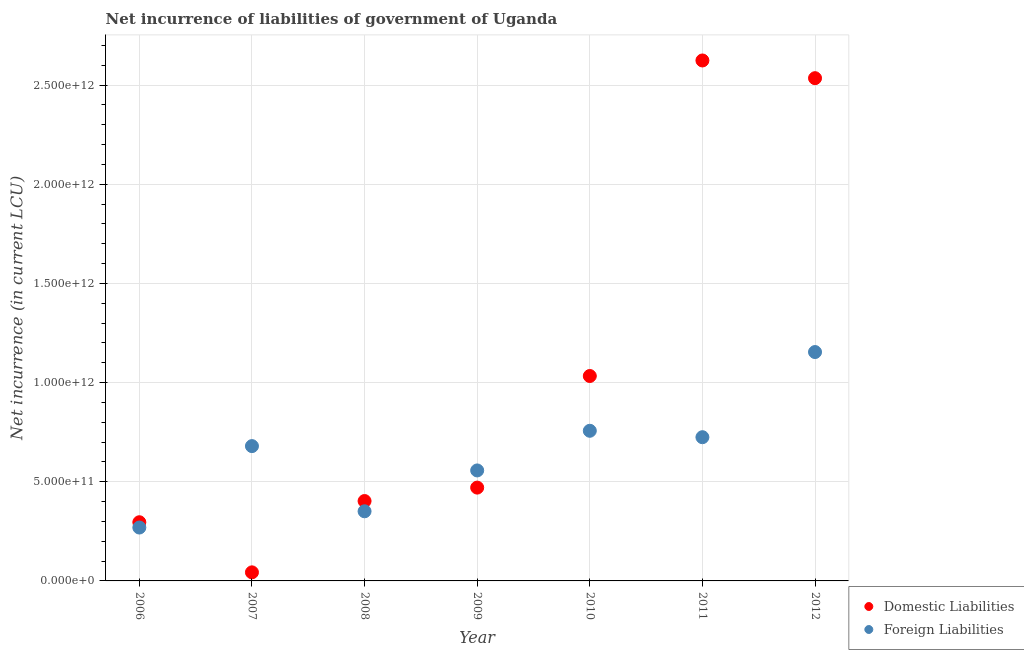How many different coloured dotlines are there?
Provide a succinct answer. 2. Is the number of dotlines equal to the number of legend labels?
Provide a succinct answer. Yes. What is the net incurrence of foreign liabilities in 2012?
Provide a succinct answer. 1.15e+12. Across all years, what is the maximum net incurrence of domestic liabilities?
Your answer should be compact. 2.62e+12. Across all years, what is the minimum net incurrence of domestic liabilities?
Provide a short and direct response. 4.32e+1. What is the total net incurrence of domestic liabilities in the graph?
Keep it short and to the point. 7.40e+12. What is the difference between the net incurrence of domestic liabilities in 2009 and that in 2010?
Your answer should be very brief. -5.63e+11. What is the difference between the net incurrence of foreign liabilities in 2010 and the net incurrence of domestic liabilities in 2009?
Give a very brief answer. 2.86e+11. What is the average net incurrence of foreign liabilities per year?
Your answer should be compact. 6.42e+11. In the year 2008, what is the difference between the net incurrence of domestic liabilities and net incurrence of foreign liabilities?
Give a very brief answer. 5.17e+1. What is the ratio of the net incurrence of foreign liabilities in 2007 to that in 2010?
Offer a terse response. 0.9. Is the net incurrence of domestic liabilities in 2008 less than that in 2012?
Provide a succinct answer. Yes. Is the difference between the net incurrence of domestic liabilities in 2010 and 2011 greater than the difference between the net incurrence of foreign liabilities in 2010 and 2011?
Your response must be concise. No. What is the difference between the highest and the second highest net incurrence of foreign liabilities?
Ensure brevity in your answer.  3.97e+11. What is the difference between the highest and the lowest net incurrence of foreign liabilities?
Your response must be concise. 8.85e+11. In how many years, is the net incurrence of domestic liabilities greater than the average net incurrence of domestic liabilities taken over all years?
Your answer should be very brief. 2. Is the sum of the net incurrence of foreign liabilities in 2009 and 2010 greater than the maximum net incurrence of domestic liabilities across all years?
Keep it short and to the point. No. How many dotlines are there?
Offer a terse response. 2. What is the difference between two consecutive major ticks on the Y-axis?
Your response must be concise. 5.00e+11. How many legend labels are there?
Provide a short and direct response. 2. How are the legend labels stacked?
Your answer should be very brief. Vertical. What is the title of the graph?
Provide a succinct answer. Net incurrence of liabilities of government of Uganda. Does "Female labourers" appear as one of the legend labels in the graph?
Your answer should be compact. No. What is the label or title of the Y-axis?
Provide a succinct answer. Net incurrence (in current LCU). What is the Net incurrence (in current LCU) of Domestic Liabilities in 2006?
Provide a short and direct response. 2.96e+11. What is the Net incurrence (in current LCU) of Foreign Liabilities in 2006?
Keep it short and to the point. 2.69e+11. What is the Net incurrence (in current LCU) of Domestic Liabilities in 2007?
Your answer should be very brief. 4.32e+1. What is the Net incurrence (in current LCU) of Foreign Liabilities in 2007?
Offer a very short reply. 6.80e+11. What is the Net incurrence (in current LCU) in Domestic Liabilities in 2008?
Provide a short and direct response. 4.03e+11. What is the Net incurrence (in current LCU) of Foreign Liabilities in 2008?
Ensure brevity in your answer.  3.51e+11. What is the Net incurrence (in current LCU) in Domestic Liabilities in 2009?
Make the answer very short. 4.70e+11. What is the Net incurrence (in current LCU) in Foreign Liabilities in 2009?
Your answer should be very brief. 5.57e+11. What is the Net incurrence (in current LCU) in Domestic Liabilities in 2010?
Your answer should be compact. 1.03e+12. What is the Net incurrence (in current LCU) in Foreign Liabilities in 2010?
Keep it short and to the point. 7.57e+11. What is the Net incurrence (in current LCU) in Domestic Liabilities in 2011?
Make the answer very short. 2.62e+12. What is the Net incurrence (in current LCU) of Foreign Liabilities in 2011?
Provide a short and direct response. 7.25e+11. What is the Net incurrence (in current LCU) of Domestic Liabilities in 2012?
Your answer should be very brief. 2.53e+12. What is the Net incurrence (in current LCU) in Foreign Liabilities in 2012?
Your answer should be very brief. 1.15e+12. Across all years, what is the maximum Net incurrence (in current LCU) in Domestic Liabilities?
Offer a terse response. 2.62e+12. Across all years, what is the maximum Net incurrence (in current LCU) of Foreign Liabilities?
Keep it short and to the point. 1.15e+12. Across all years, what is the minimum Net incurrence (in current LCU) in Domestic Liabilities?
Your answer should be compact. 4.32e+1. Across all years, what is the minimum Net incurrence (in current LCU) of Foreign Liabilities?
Provide a short and direct response. 2.69e+11. What is the total Net incurrence (in current LCU) of Domestic Liabilities in the graph?
Ensure brevity in your answer.  7.40e+12. What is the total Net incurrence (in current LCU) of Foreign Liabilities in the graph?
Offer a very short reply. 4.49e+12. What is the difference between the Net incurrence (in current LCU) in Domestic Liabilities in 2006 and that in 2007?
Your answer should be very brief. 2.53e+11. What is the difference between the Net incurrence (in current LCU) in Foreign Liabilities in 2006 and that in 2007?
Provide a short and direct response. -4.11e+11. What is the difference between the Net incurrence (in current LCU) in Domestic Liabilities in 2006 and that in 2008?
Offer a terse response. -1.07e+11. What is the difference between the Net incurrence (in current LCU) of Foreign Liabilities in 2006 and that in 2008?
Your response must be concise. -8.19e+1. What is the difference between the Net incurrence (in current LCU) in Domestic Liabilities in 2006 and that in 2009?
Give a very brief answer. -1.75e+11. What is the difference between the Net incurrence (in current LCU) of Foreign Liabilities in 2006 and that in 2009?
Make the answer very short. -2.88e+11. What is the difference between the Net incurrence (in current LCU) of Domestic Liabilities in 2006 and that in 2010?
Give a very brief answer. -7.37e+11. What is the difference between the Net incurrence (in current LCU) of Foreign Liabilities in 2006 and that in 2010?
Keep it short and to the point. -4.88e+11. What is the difference between the Net incurrence (in current LCU) of Domestic Liabilities in 2006 and that in 2011?
Your answer should be very brief. -2.33e+12. What is the difference between the Net incurrence (in current LCU) in Foreign Liabilities in 2006 and that in 2011?
Offer a terse response. -4.55e+11. What is the difference between the Net incurrence (in current LCU) in Domestic Liabilities in 2006 and that in 2012?
Provide a succinct answer. -2.24e+12. What is the difference between the Net incurrence (in current LCU) in Foreign Liabilities in 2006 and that in 2012?
Provide a succinct answer. -8.85e+11. What is the difference between the Net incurrence (in current LCU) in Domestic Liabilities in 2007 and that in 2008?
Ensure brevity in your answer.  -3.60e+11. What is the difference between the Net incurrence (in current LCU) in Foreign Liabilities in 2007 and that in 2008?
Your answer should be compact. 3.29e+11. What is the difference between the Net incurrence (in current LCU) of Domestic Liabilities in 2007 and that in 2009?
Your answer should be very brief. -4.27e+11. What is the difference between the Net incurrence (in current LCU) in Foreign Liabilities in 2007 and that in 2009?
Offer a very short reply. 1.23e+11. What is the difference between the Net incurrence (in current LCU) in Domestic Liabilities in 2007 and that in 2010?
Keep it short and to the point. -9.90e+11. What is the difference between the Net incurrence (in current LCU) in Foreign Liabilities in 2007 and that in 2010?
Your answer should be very brief. -7.73e+1. What is the difference between the Net incurrence (in current LCU) of Domestic Liabilities in 2007 and that in 2011?
Offer a terse response. -2.58e+12. What is the difference between the Net incurrence (in current LCU) of Foreign Liabilities in 2007 and that in 2011?
Provide a succinct answer. -4.49e+1. What is the difference between the Net incurrence (in current LCU) of Domestic Liabilities in 2007 and that in 2012?
Keep it short and to the point. -2.49e+12. What is the difference between the Net incurrence (in current LCU) in Foreign Liabilities in 2007 and that in 2012?
Your answer should be very brief. -4.74e+11. What is the difference between the Net incurrence (in current LCU) of Domestic Liabilities in 2008 and that in 2009?
Give a very brief answer. -6.77e+1. What is the difference between the Net incurrence (in current LCU) of Foreign Liabilities in 2008 and that in 2009?
Your answer should be compact. -2.06e+11. What is the difference between the Net incurrence (in current LCU) of Domestic Liabilities in 2008 and that in 2010?
Give a very brief answer. -6.30e+11. What is the difference between the Net incurrence (in current LCU) of Foreign Liabilities in 2008 and that in 2010?
Offer a very short reply. -4.06e+11. What is the difference between the Net incurrence (in current LCU) in Domestic Liabilities in 2008 and that in 2011?
Offer a very short reply. -2.22e+12. What is the difference between the Net incurrence (in current LCU) of Foreign Liabilities in 2008 and that in 2011?
Give a very brief answer. -3.74e+11. What is the difference between the Net incurrence (in current LCU) in Domestic Liabilities in 2008 and that in 2012?
Ensure brevity in your answer.  -2.13e+12. What is the difference between the Net incurrence (in current LCU) in Foreign Liabilities in 2008 and that in 2012?
Your answer should be very brief. -8.03e+11. What is the difference between the Net incurrence (in current LCU) of Domestic Liabilities in 2009 and that in 2010?
Your answer should be compact. -5.63e+11. What is the difference between the Net incurrence (in current LCU) in Foreign Liabilities in 2009 and that in 2010?
Provide a succinct answer. -2.00e+11. What is the difference between the Net incurrence (in current LCU) in Domestic Liabilities in 2009 and that in 2011?
Provide a succinct answer. -2.15e+12. What is the difference between the Net incurrence (in current LCU) in Foreign Liabilities in 2009 and that in 2011?
Provide a succinct answer. -1.68e+11. What is the difference between the Net incurrence (in current LCU) in Domestic Liabilities in 2009 and that in 2012?
Your response must be concise. -2.06e+12. What is the difference between the Net incurrence (in current LCU) of Foreign Liabilities in 2009 and that in 2012?
Offer a very short reply. -5.97e+11. What is the difference between the Net incurrence (in current LCU) of Domestic Liabilities in 2010 and that in 2011?
Your answer should be compact. -1.59e+12. What is the difference between the Net incurrence (in current LCU) in Foreign Liabilities in 2010 and that in 2011?
Your answer should be compact. 3.24e+1. What is the difference between the Net incurrence (in current LCU) of Domestic Liabilities in 2010 and that in 2012?
Your response must be concise. -1.50e+12. What is the difference between the Net incurrence (in current LCU) in Foreign Liabilities in 2010 and that in 2012?
Your answer should be compact. -3.97e+11. What is the difference between the Net incurrence (in current LCU) in Domestic Liabilities in 2011 and that in 2012?
Keep it short and to the point. 8.93e+1. What is the difference between the Net incurrence (in current LCU) of Foreign Liabilities in 2011 and that in 2012?
Your response must be concise. -4.29e+11. What is the difference between the Net incurrence (in current LCU) in Domestic Liabilities in 2006 and the Net incurrence (in current LCU) in Foreign Liabilities in 2007?
Your answer should be very brief. -3.84e+11. What is the difference between the Net incurrence (in current LCU) in Domestic Liabilities in 2006 and the Net incurrence (in current LCU) in Foreign Liabilities in 2008?
Give a very brief answer. -5.52e+1. What is the difference between the Net incurrence (in current LCU) in Domestic Liabilities in 2006 and the Net incurrence (in current LCU) in Foreign Liabilities in 2009?
Your response must be concise. -2.61e+11. What is the difference between the Net incurrence (in current LCU) of Domestic Liabilities in 2006 and the Net incurrence (in current LCU) of Foreign Liabilities in 2010?
Offer a terse response. -4.61e+11. What is the difference between the Net incurrence (in current LCU) of Domestic Liabilities in 2006 and the Net incurrence (in current LCU) of Foreign Liabilities in 2011?
Give a very brief answer. -4.29e+11. What is the difference between the Net incurrence (in current LCU) of Domestic Liabilities in 2006 and the Net incurrence (in current LCU) of Foreign Liabilities in 2012?
Give a very brief answer. -8.58e+11. What is the difference between the Net incurrence (in current LCU) in Domestic Liabilities in 2007 and the Net incurrence (in current LCU) in Foreign Liabilities in 2008?
Your answer should be compact. -3.08e+11. What is the difference between the Net incurrence (in current LCU) in Domestic Liabilities in 2007 and the Net incurrence (in current LCU) in Foreign Liabilities in 2009?
Offer a very short reply. -5.14e+11. What is the difference between the Net incurrence (in current LCU) in Domestic Liabilities in 2007 and the Net incurrence (in current LCU) in Foreign Liabilities in 2010?
Ensure brevity in your answer.  -7.14e+11. What is the difference between the Net incurrence (in current LCU) in Domestic Liabilities in 2007 and the Net incurrence (in current LCU) in Foreign Liabilities in 2011?
Keep it short and to the point. -6.81e+11. What is the difference between the Net incurrence (in current LCU) in Domestic Liabilities in 2007 and the Net incurrence (in current LCU) in Foreign Liabilities in 2012?
Make the answer very short. -1.11e+12. What is the difference between the Net incurrence (in current LCU) of Domestic Liabilities in 2008 and the Net incurrence (in current LCU) of Foreign Liabilities in 2009?
Offer a very short reply. -1.54e+11. What is the difference between the Net incurrence (in current LCU) in Domestic Liabilities in 2008 and the Net incurrence (in current LCU) in Foreign Liabilities in 2010?
Keep it short and to the point. -3.54e+11. What is the difference between the Net incurrence (in current LCU) in Domestic Liabilities in 2008 and the Net incurrence (in current LCU) in Foreign Liabilities in 2011?
Offer a terse response. -3.22e+11. What is the difference between the Net incurrence (in current LCU) of Domestic Liabilities in 2008 and the Net incurrence (in current LCU) of Foreign Liabilities in 2012?
Keep it short and to the point. -7.51e+11. What is the difference between the Net incurrence (in current LCU) in Domestic Liabilities in 2009 and the Net incurrence (in current LCU) in Foreign Liabilities in 2010?
Offer a terse response. -2.86e+11. What is the difference between the Net incurrence (in current LCU) of Domestic Liabilities in 2009 and the Net incurrence (in current LCU) of Foreign Liabilities in 2011?
Your response must be concise. -2.54e+11. What is the difference between the Net incurrence (in current LCU) in Domestic Liabilities in 2009 and the Net incurrence (in current LCU) in Foreign Liabilities in 2012?
Provide a short and direct response. -6.83e+11. What is the difference between the Net incurrence (in current LCU) in Domestic Liabilities in 2010 and the Net incurrence (in current LCU) in Foreign Liabilities in 2011?
Keep it short and to the point. 3.09e+11. What is the difference between the Net incurrence (in current LCU) in Domestic Liabilities in 2010 and the Net incurrence (in current LCU) in Foreign Liabilities in 2012?
Offer a very short reply. -1.21e+11. What is the difference between the Net incurrence (in current LCU) in Domestic Liabilities in 2011 and the Net incurrence (in current LCU) in Foreign Liabilities in 2012?
Offer a terse response. 1.47e+12. What is the average Net incurrence (in current LCU) of Domestic Liabilities per year?
Make the answer very short. 1.06e+12. What is the average Net incurrence (in current LCU) in Foreign Liabilities per year?
Provide a short and direct response. 6.42e+11. In the year 2006, what is the difference between the Net incurrence (in current LCU) in Domestic Liabilities and Net incurrence (in current LCU) in Foreign Liabilities?
Offer a terse response. 2.67e+1. In the year 2007, what is the difference between the Net incurrence (in current LCU) of Domestic Liabilities and Net incurrence (in current LCU) of Foreign Liabilities?
Your answer should be compact. -6.36e+11. In the year 2008, what is the difference between the Net incurrence (in current LCU) of Domestic Liabilities and Net incurrence (in current LCU) of Foreign Liabilities?
Make the answer very short. 5.17e+1. In the year 2009, what is the difference between the Net incurrence (in current LCU) of Domestic Liabilities and Net incurrence (in current LCU) of Foreign Liabilities?
Provide a succinct answer. -8.66e+1. In the year 2010, what is the difference between the Net incurrence (in current LCU) of Domestic Liabilities and Net incurrence (in current LCU) of Foreign Liabilities?
Your response must be concise. 2.76e+11. In the year 2011, what is the difference between the Net incurrence (in current LCU) in Domestic Liabilities and Net incurrence (in current LCU) in Foreign Liabilities?
Provide a short and direct response. 1.90e+12. In the year 2012, what is the difference between the Net incurrence (in current LCU) of Domestic Liabilities and Net incurrence (in current LCU) of Foreign Liabilities?
Keep it short and to the point. 1.38e+12. What is the ratio of the Net incurrence (in current LCU) of Domestic Liabilities in 2006 to that in 2007?
Keep it short and to the point. 6.84. What is the ratio of the Net incurrence (in current LCU) in Foreign Liabilities in 2006 to that in 2007?
Offer a terse response. 0.4. What is the ratio of the Net incurrence (in current LCU) of Domestic Liabilities in 2006 to that in 2008?
Your answer should be very brief. 0.73. What is the ratio of the Net incurrence (in current LCU) in Foreign Liabilities in 2006 to that in 2008?
Offer a terse response. 0.77. What is the ratio of the Net incurrence (in current LCU) of Domestic Liabilities in 2006 to that in 2009?
Keep it short and to the point. 0.63. What is the ratio of the Net incurrence (in current LCU) of Foreign Liabilities in 2006 to that in 2009?
Your answer should be compact. 0.48. What is the ratio of the Net incurrence (in current LCU) of Domestic Liabilities in 2006 to that in 2010?
Provide a short and direct response. 0.29. What is the ratio of the Net incurrence (in current LCU) of Foreign Liabilities in 2006 to that in 2010?
Offer a terse response. 0.36. What is the ratio of the Net incurrence (in current LCU) in Domestic Liabilities in 2006 to that in 2011?
Offer a very short reply. 0.11. What is the ratio of the Net incurrence (in current LCU) in Foreign Liabilities in 2006 to that in 2011?
Offer a terse response. 0.37. What is the ratio of the Net incurrence (in current LCU) in Domestic Liabilities in 2006 to that in 2012?
Provide a succinct answer. 0.12. What is the ratio of the Net incurrence (in current LCU) in Foreign Liabilities in 2006 to that in 2012?
Your answer should be very brief. 0.23. What is the ratio of the Net incurrence (in current LCU) in Domestic Liabilities in 2007 to that in 2008?
Provide a succinct answer. 0.11. What is the ratio of the Net incurrence (in current LCU) of Foreign Liabilities in 2007 to that in 2008?
Provide a succinct answer. 1.94. What is the ratio of the Net incurrence (in current LCU) of Domestic Liabilities in 2007 to that in 2009?
Ensure brevity in your answer.  0.09. What is the ratio of the Net incurrence (in current LCU) of Foreign Liabilities in 2007 to that in 2009?
Provide a short and direct response. 1.22. What is the ratio of the Net incurrence (in current LCU) of Domestic Liabilities in 2007 to that in 2010?
Give a very brief answer. 0.04. What is the ratio of the Net incurrence (in current LCU) in Foreign Liabilities in 2007 to that in 2010?
Your answer should be very brief. 0.9. What is the ratio of the Net incurrence (in current LCU) of Domestic Liabilities in 2007 to that in 2011?
Your answer should be very brief. 0.02. What is the ratio of the Net incurrence (in current LCU) of Foreign Liabilities in 2007 to that in 2011?
Your answer should be compact. 0.94. What is the ratio of the Net incurrence (in current LCU) in Domestic Liabilities in 2007 to that in 2012?
Provide a short and direct response. 0.02. What is the ratio of the Net incurrence (in current LCU) of Foreign Liabilities in 2007 to that in 2012?
Your answer should be compact. 0.59. What is the ratio of the Net incurrence (in current LCU) in Domestic Liabilities in 2008 to that in 2009?
Offer a terse response. 0.86. What is the ratio of the Net incurrence (in current LCU) of Foreign Liabilities in 2008 to that in 2009?
Ensure brevity in your answer.  0.63. What is the ratio of the Net incurrence (in current LCU) in Domestic Liabilities in 2008 to that in 2010?
Give a very brief answer. 0.39. What is the ratio of the Net incurrence (in current LCU) in Foreign Liabilities in 2008 to that in 2010?
Ensure brevity in your answer.  0.46. What is the ratio of the Net incurrence (in current LCU) in Domestic Liabilities in 2008 to that in 2011?
Your response must be concise. 0.15. What is the ratio of the Net incurrence (in current LCU) of Foreign Liabilities in 2008 to that in 2011?
Keep it short and to the point. 0.48. What is the ratio of the Net incurrence (in current LCU) in Domestic Liabilities in 2008 to that in 2012?
Your answer should be compact. 0.16. What is the ratio of the Net incurrence (in current LCU) of Foreign Liabilities in 2008 to that in 2012?
Provide a succinct answer. 0.3. What is the ratio of the Net incurrence (in current LCU) in Domestic Liabilities in 2009 to that in 2010?
Your answer should be compact. 0.46. What is the ratio of the Net incurrence (in current LCU) of Foreign Liabilities in 2009 to that in 2010?
Offer a very short reply. 0.74. What is the ratio of the Net incurrence (in current LCU) of Domestic Liabilities in 2009 to that in 2011?
Make the answer very short. 0.18. What is the ratio of the Net incurrence (in current LCU) of Foreign Liabilities in 2009 to that in 2011?
Give a very brief answer. 0.77. What is the ratio of the Net incurrence (in current LCU) in Domestic Liabilities in 2009 to that in 2012?
Your response must be concise. 0.19. What is the ratio of the Net incurrence (in current LCU) of Foreign Liabilities in 2009 to that in 2012?
Give a very brief answer. 0.48. What is the ratio of the Net incurrence (in current LCU) in Domestic Liabilities in 2010 to that in 2011?
Your answer should be very brief. 0.39. What is the ratio of the Net incurrence (in current LCU) of Foreign Liabilities in 2010 to that in 2011?
Keep it short and to the point. 1.04. What is the ratio of the Net incurrence (in current LCU) of Domestic Liabilities in 2010 to that in 2012?
Your response must be concise. 0.41. What is the ratio of the Net incurrence (in current LCU) of Foreign Liabilities in 2010 to that in 2012?
Offer a very short reply. 0.66. What is the ratio of the Net incurrence (in current LCU) of Domestic Liabilities in 2011 to that in 2012?
Keep it short and to the point. 1.04. What is the ratio of the Net incurrence (in current LCU) of Foreign Liabilities in 2011 to that in 2012?
Provide a succinct answer. 0.63. What is the difference between the highest and the second highest Net incurrence (in current LCU) in Domestic Liabilities?
Give a very brief answer. 8.93e+1. What is the difference between the highest and the second highest Net incurrence (in current LCU) of Foreign Liabilities?
Provide a succinct answer. 3.97e+11. What is the difference between the highest and the lowest Net incurrence (in current LCU) of Domestic Liabilities?
Provide a short and direct response. 2.58e+12. What is the difference between the highest and the lowest Net incurrence (in current LCU) of Foreign Liabilities?
Offer a very short reply. 8.85e+11. 